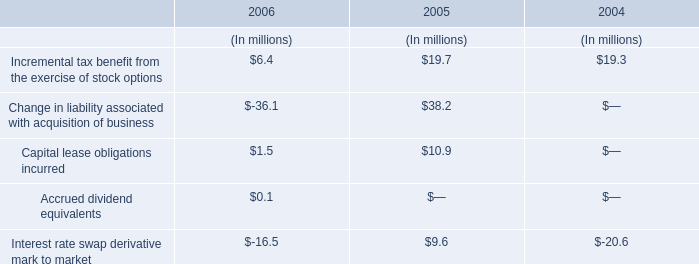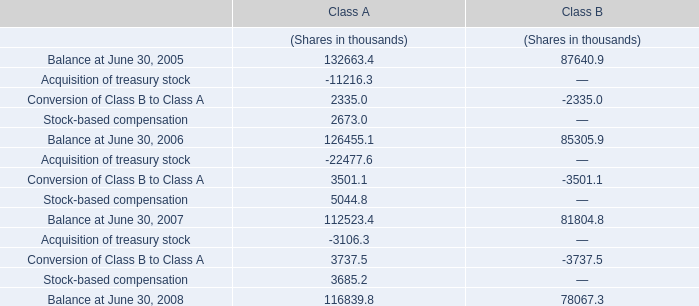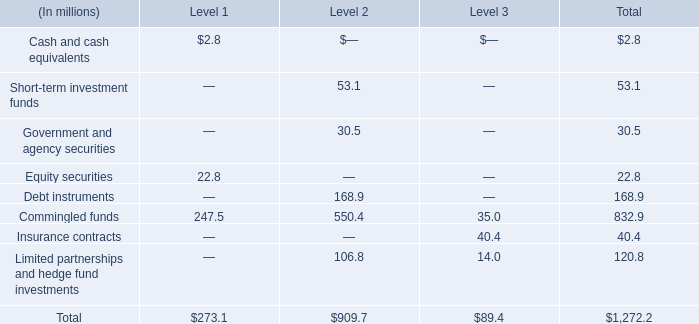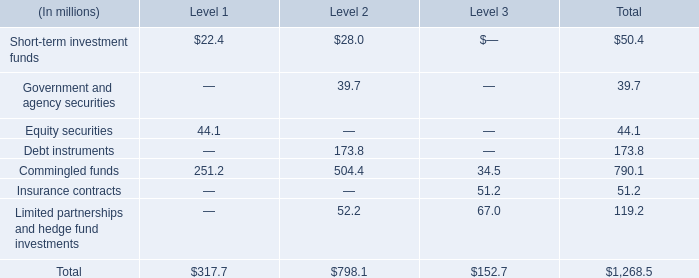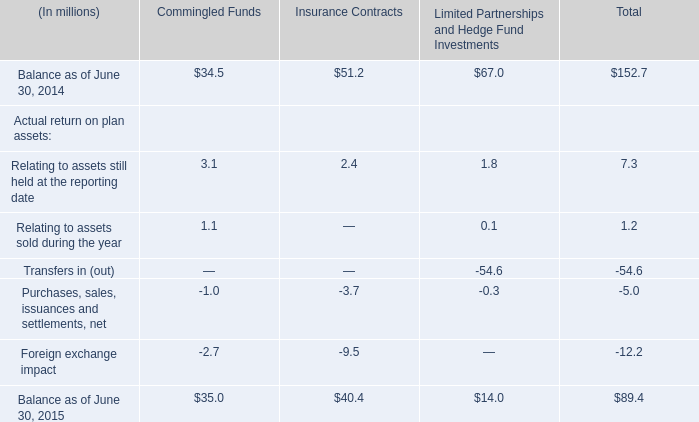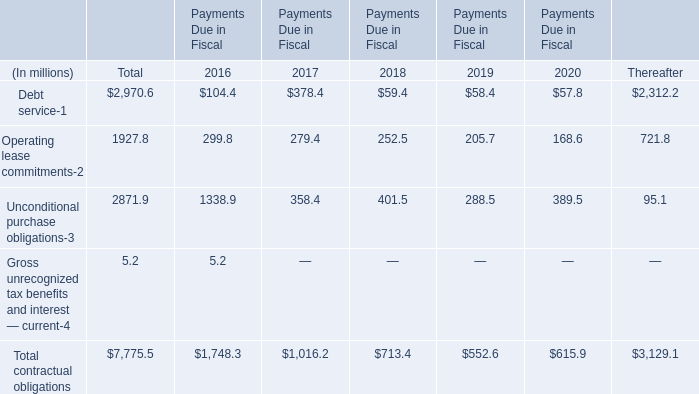What's the sum of all elements that are greater than 100 in section Total? (in dollars in millions) 
Computations: ((173.8 + 790.1) + 119.2)
Answer: 1083.1. 